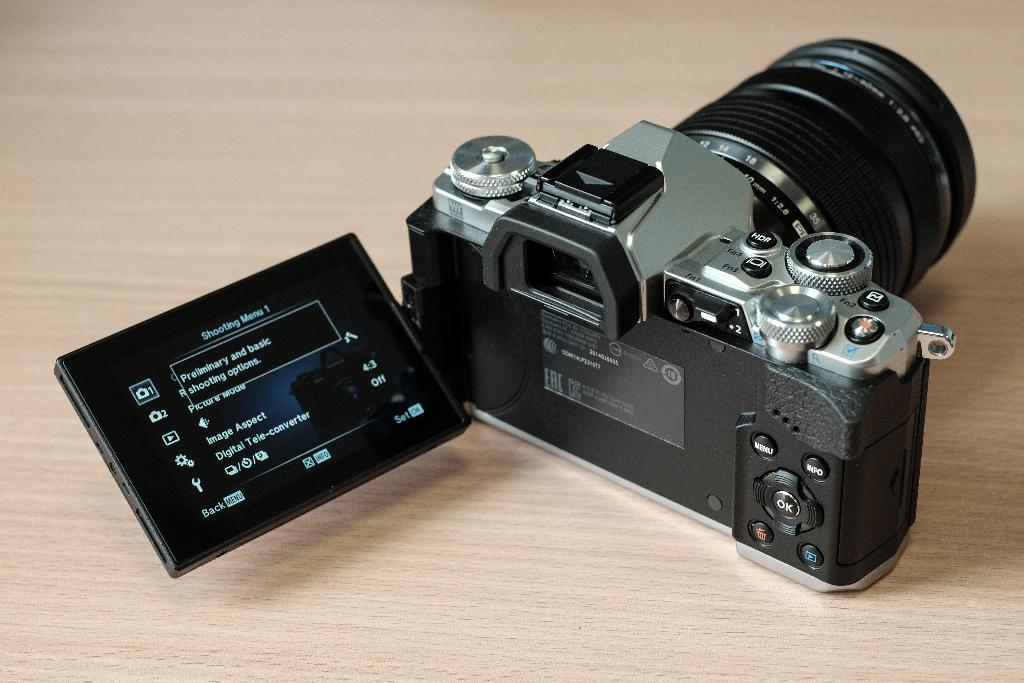What object is the main focus of the image? There is a camera in the image. Where is the camera located in the image? The camera is in the center of the image. On what surface is the camera placed? The camera is on a table. What type of cover is protecting the camera in the image? There is no cover visible on the camera in the image. 